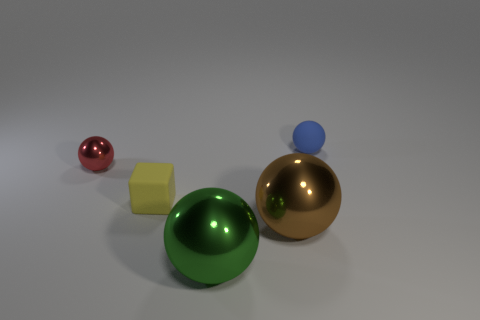The tiny ball that is left of the tiny thing behind the sphere that is to the left of the yellow rubber object is what color?
Ensure brevity in your answer.  Red. There is a shiny object that is in front of the large sphere that is on the right side of the large green metal ball; what shape is it?
Give a very brief answer. Sphere. Is the number of small yellow matte blocks that are to the right of the tiny yellow rubber cube greater than the number of blue objects?
Your answer should be compact. No. Does the large shiny thing that is on the right side of the large green object have the same shape as the large green object?
Your answer should be very brief. Yes. Are there any purple things that have the same shape as the big brown metal object?
Make the answer very short. No. What number of objects are either small objects that are behind the tiny yellow object or small shiny things?
Keep it short and to the point. 2. Is the number of brown metallic objects greater than the number of tiny brown metallic spheres?
Ensure brevity in your answer.  Yes. Is there a matte ball that has the same size as the brown metallic object?
Your response must be concise. No. How many things are spheres right of the large brown object or small spheres that are in front of the blue rubber sphere?
Your answer should be very brief. 2. There is a tiny sphere that is on the right side of the rubber thing that is in front of the small blue matte object; what is its color?
Offer a very short reply. Blue. 